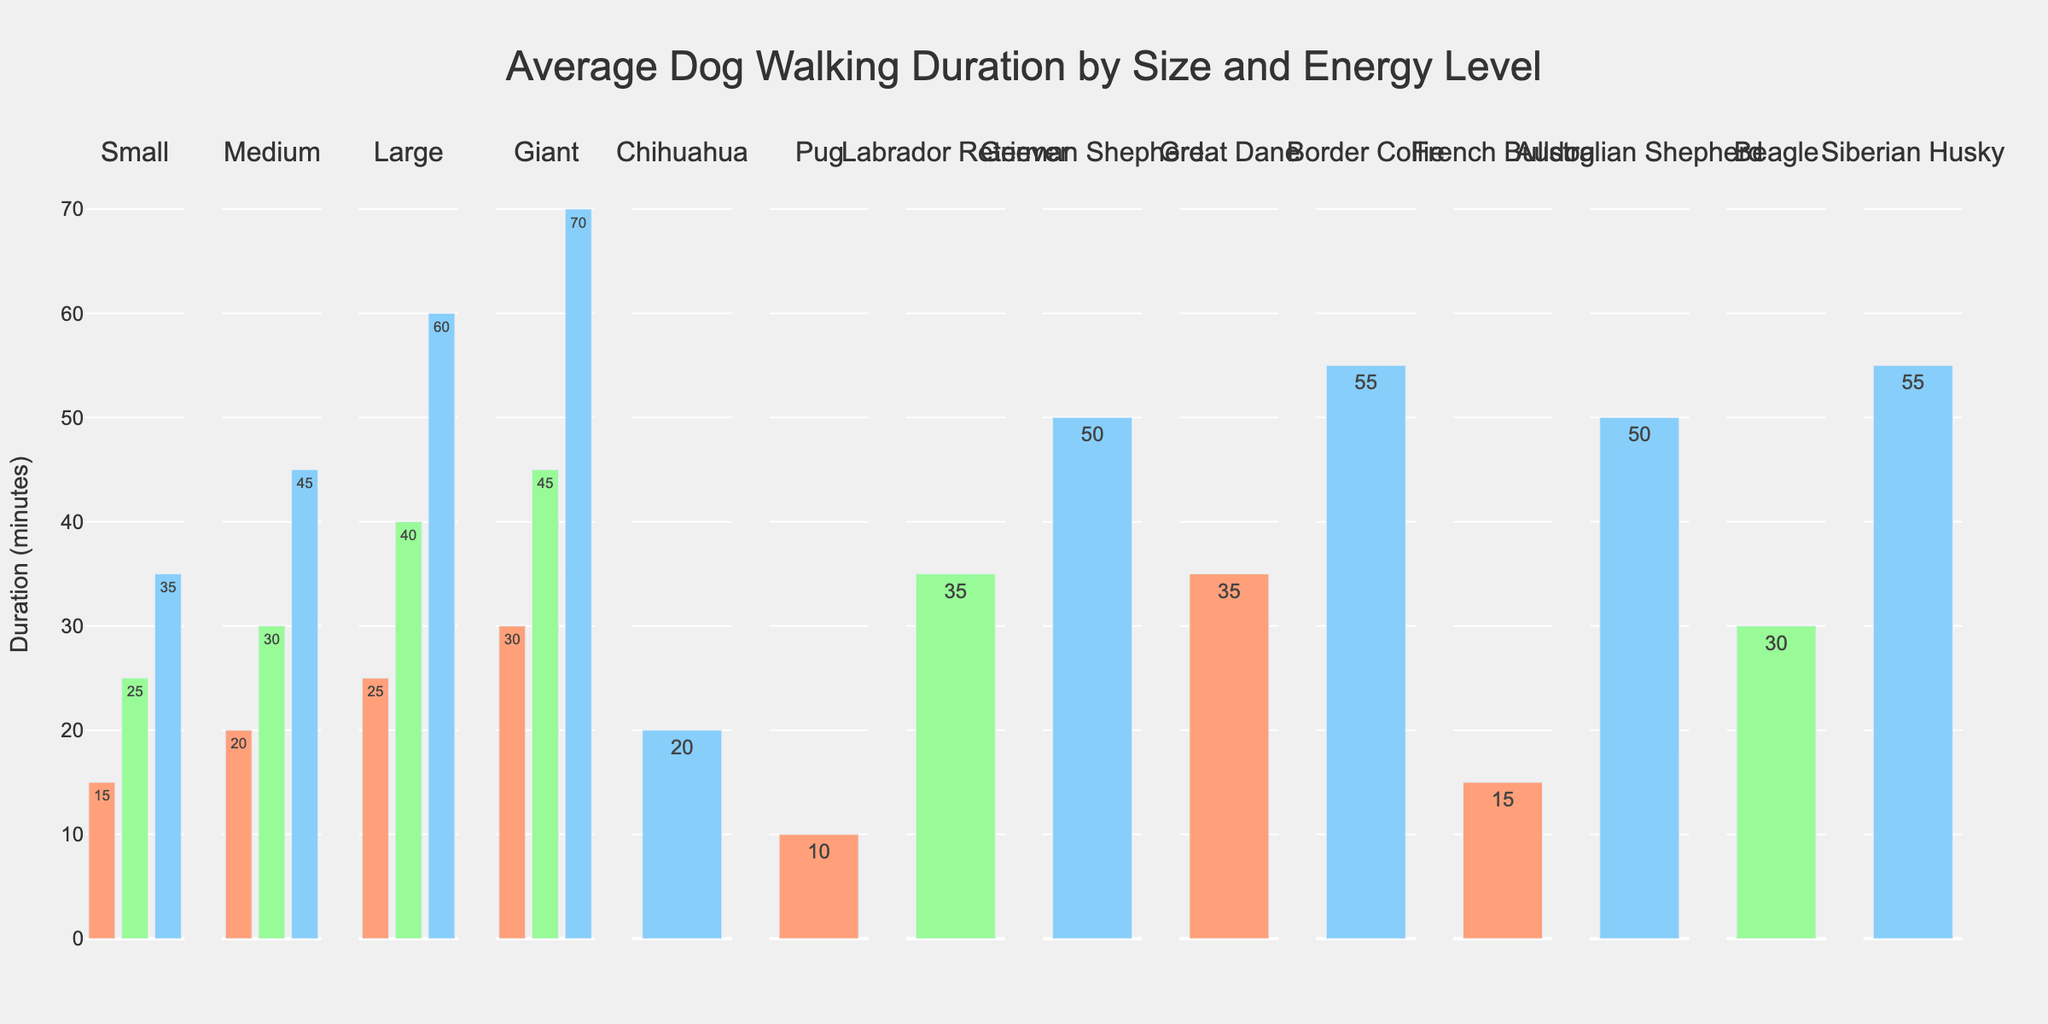What's the difference in average walk duration between Medium and High energy dogs for the Giant size? For the Giant size, the Average Walk Duration for Medium energy is 45 minutes and for High energy is 70 minutes. The difference is 70 - 45 = 25 minutes.
Answer: 25 minutes Which dog size and energy level combination has the highest average walk duration? By comparing all the bars in the chart, the highest average walk duration is found for Giant size with High energy level, which is 70 minutes.
Answer: Giant, High energy What's the average walk duration for Small size dogs across all energy levels? Sum the average durations for Small dogs: 15 (Low) + 25 (Medium) + 35 (High) = 75 minutes, then divide by the number of energy levels (3). The average is 75/3 = 25 minutes.
Answer: 25 minutes Compare the average walk duration for High energy dogs between Medium and Large sizes. Which size has a longer duration and by how much? The average walk duration for High energy dogs is 45 minutes for Medium size and 60 minutes for Large size. The Large size duration is longer by 60 - 45 = 15 minutes.
Answer: Large, 15 minutes What is the combined average walk duration for all Low energy dogs regardless of size? Sum the average durations for Low energy dogs across sizes: Small (15) + Medium (20) + Large (25) + Giant (30) = 90 minutes.
Answer: 90 minutes How does the walking duration for High energy Chihuahuas compare to High energy Small dogs in general? High energy Chihuahuas have a duration of 20 minutes, while High energy Small dogs have 35 minutes. The Chihuahuas' duration is 35 - 20 = 15 minutes shorter.
Answer: 15 minutes shorter Identify the dog with the lowest average walk duration and specify its size and energy level. The dog with the lowest average walk duration is the Pug with Low energy level at 10 minutes.
Answer: Pug, Low energy 